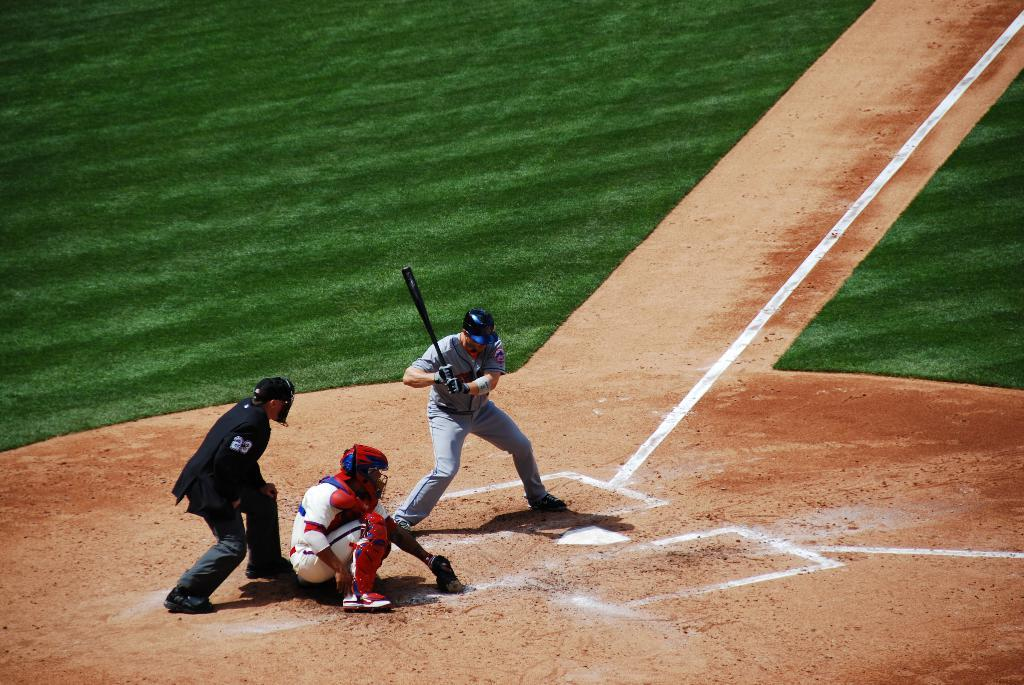What sport are the three people playing in the image? The three people are playing baseball in the image. What equipment is the person holding a bat wearing? The person holding a bat is wearing a helmet and gloves. How many people are wearing helmets in the image? Two persons are wearing helmets in the image. What type of surface is the game being played on? There is grass on the ground in the image. How many eyes can be seen on the apparatus in the image? There is no apparatus with eyes present in the image. 